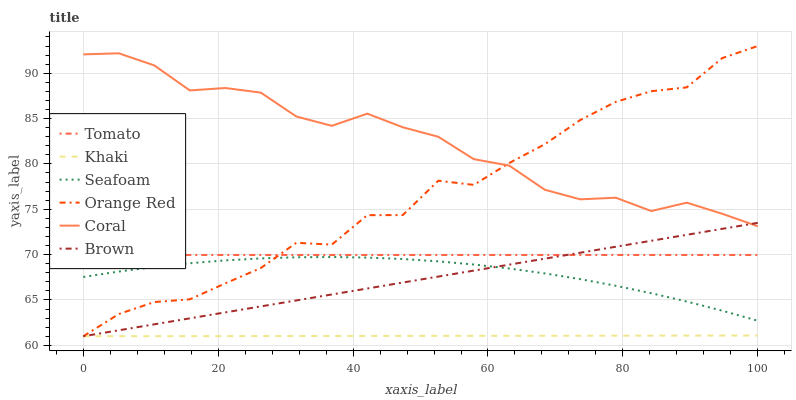Does Khaki have the minimum area under the curve?
Answer yes or no. Yes. Does Coral have the maximum area under the curve?
Answer yes or no. Yes. Does Brown have the minimum area under the curve?
Answer yes or no. No. Does Brown have the maximum area under the curve?
Answer yes or no. No. Is Khaki the smoothest?
Answer yes or no. Yes. Is Orange Red the roughest?
Answer yes or no. Yes. Is Brown the smoothest?
Answer yes or no. No. Is Brown the roughest?
Answer yes or no. No. Does Brown have the lowest value?
Answer yes or no. Yes. Does Coral have the lowest value?
Answer yes or no. No. Does Orange Red have the highest value?
Answer yes or no. Yes. Does Brown have the highest value?
Answer yes or no. No. Is Seafoam less than Tomato?
Answer yes or no. Yes. Is Tomato greater than Seafoam?
Answer yes or no. Yes. Does Tomato intersect Brown?
Answer yes or no. Yes. Is Tomato less than Brown?
Answer yes or no. No. Is Tomato greater than Brown?
Answer yes or no. No. Does Seafoam intersect Tomato?
Answer yes or no. No. 